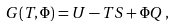<formula> <loc_0><loc_0><loc_500><loc_500>G ( T , \Phi ) = U - T S + \Phi Q \, ,</formula> 